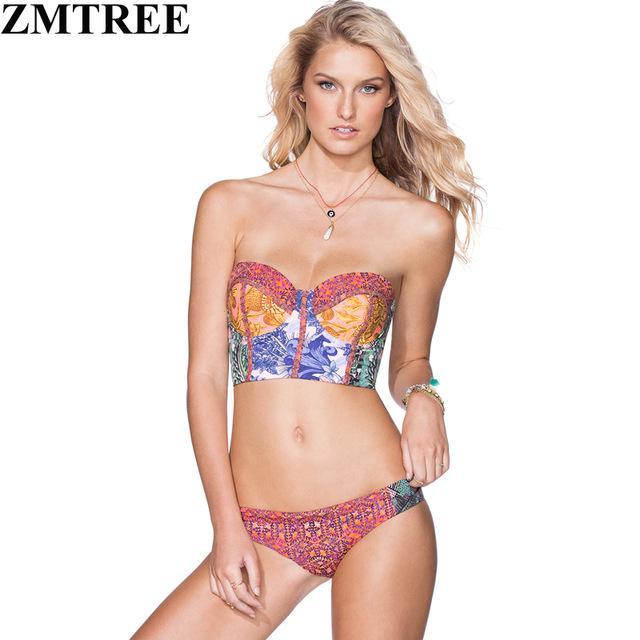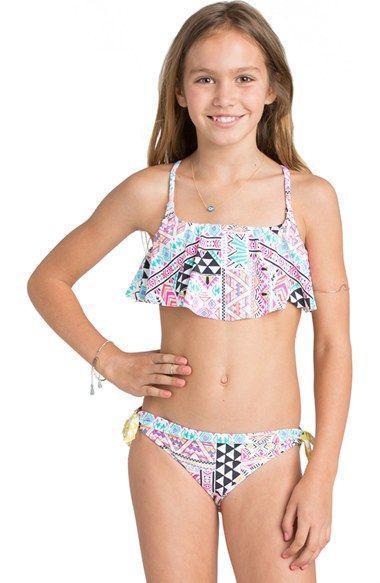The first image is the image on the left, the second image is the image on the right. Examine the images to the left and right. Is the description "At least one person is wearing a bracelet." accurate? Answer yes or no. Yes. The first image is the image on the left, the second image is the image on the right. Given the left and right images, does the statement "The model in one of the images does not have her right arm hanging by her side." hold true? Answer yes or no. Yes. 